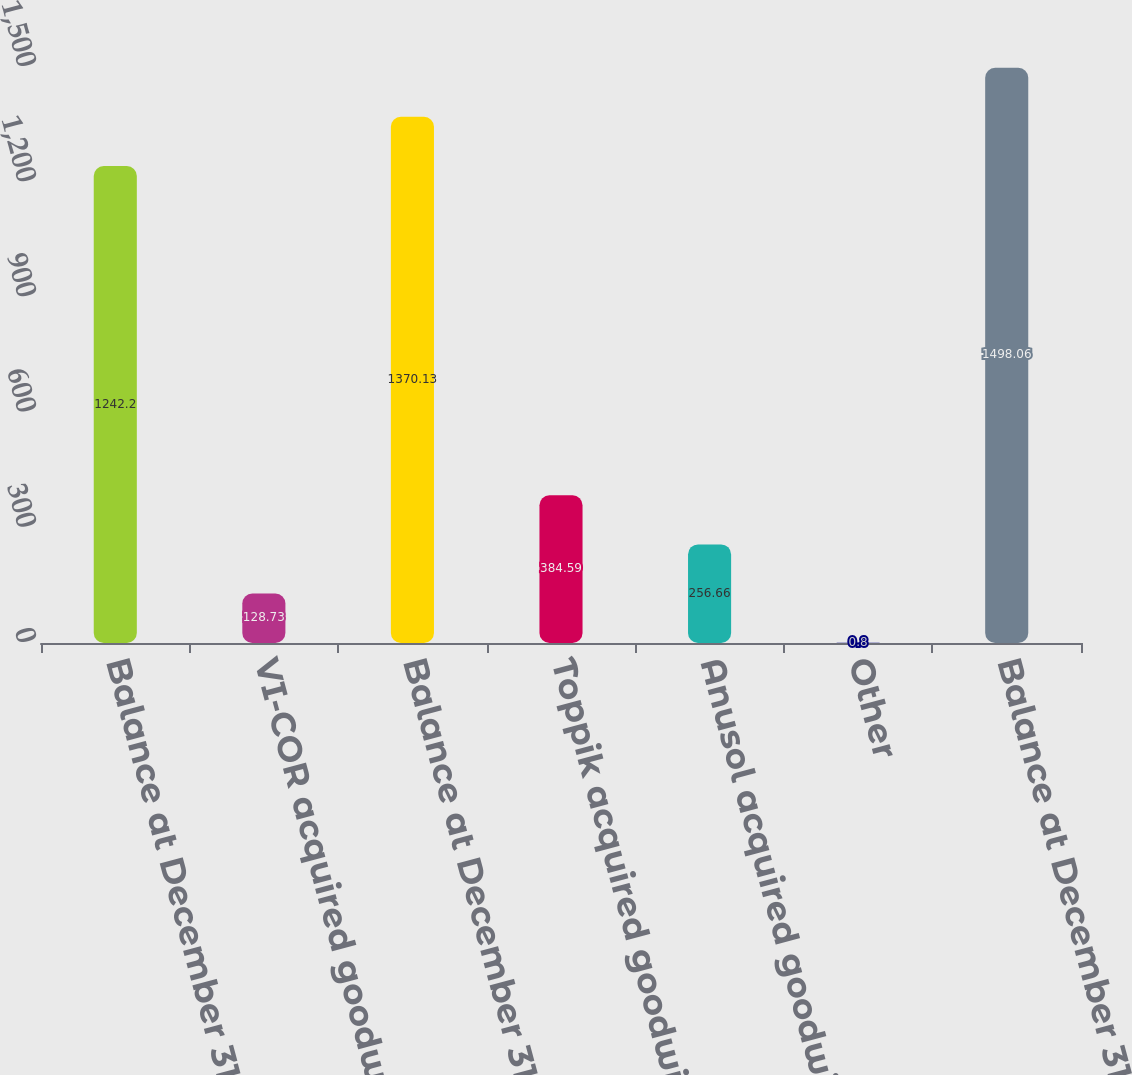Convert chart to OTSL. <chart><loc_0><loc_0><loc_500><loc_500><bar_chart><fcel>Balance at December 31 2014<fcel>VI-COR acquired goodwill<fcel>Balance at December 31 2015<fcel>Toppik acquired goodwill<fcel>Anusol acquired goodwill<fcel>Other<fcel>Balance at December 31 2016<nl><fcel>1242.2<fcel>128.73<fcel>1370.13<fcel>384.59<fcel>256.66<fcel>0.8<fcel>1498.06<nl></chart> 